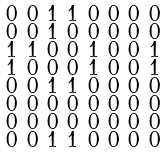<formula> <loc_0><loc_0><loc_500><loc_500>\begin{smallmatrix} 0 & 0 & 1 & 1 & 0 & 0 & 0 & 0 \\ 0 & 0 & 1 & 0 & 0 & 0 & 0 & 0 \\ 1 & 1 & 0 & 0 & 1 & 0 & 0 & 1 \\ 1 & 0 & 0 & 0 & 1 & 0 & 0 & 1 \\ 0 & 0 & 1 & 1 & 0 & 0 & 0 & 0 \\ 0 & 0 & 0 & 0 & 0 & 0 & 0 & 0 \\ 0 & 0 & 0 & 0 & 0 & 0 & 0 & 0 \\ 0 & 0 & 1 & 1 & 0 & 0 & 0 & 0 \end{smallmatrix}</formula> 